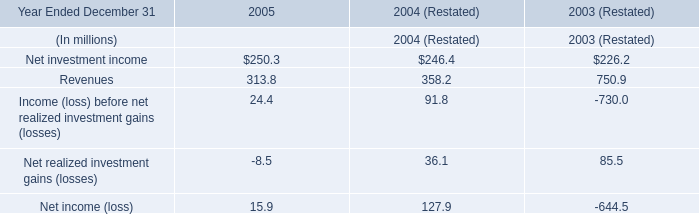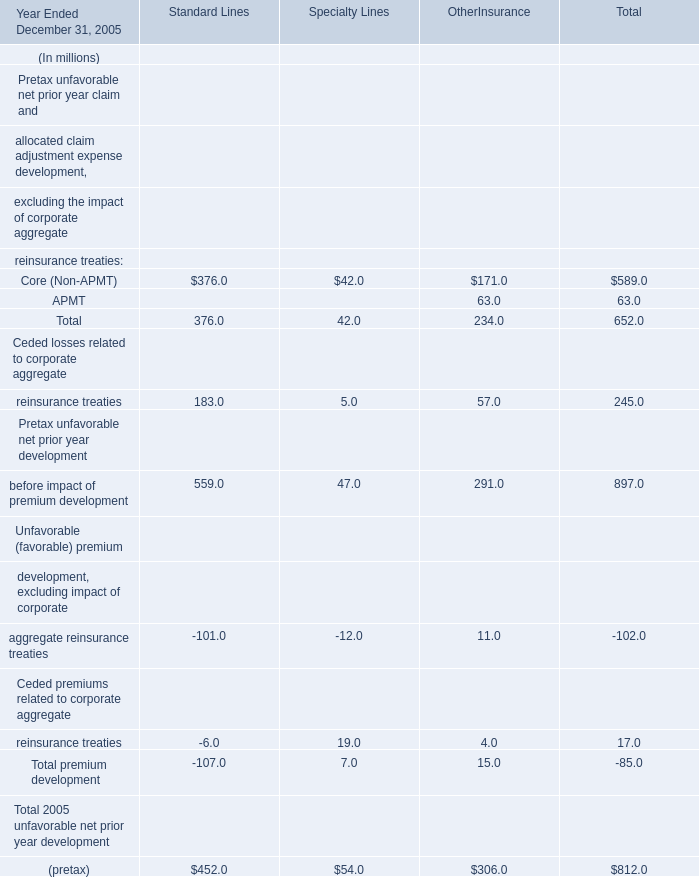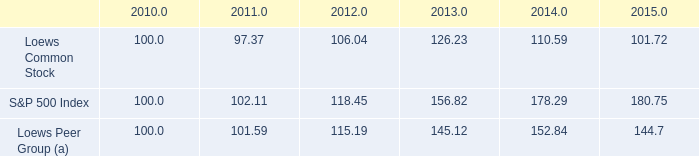what is the roi of an investment in loews common stock from 2010 to 2011? 
Computations: ((97.37 - 100) / 100)
Answer: -0.0263. 